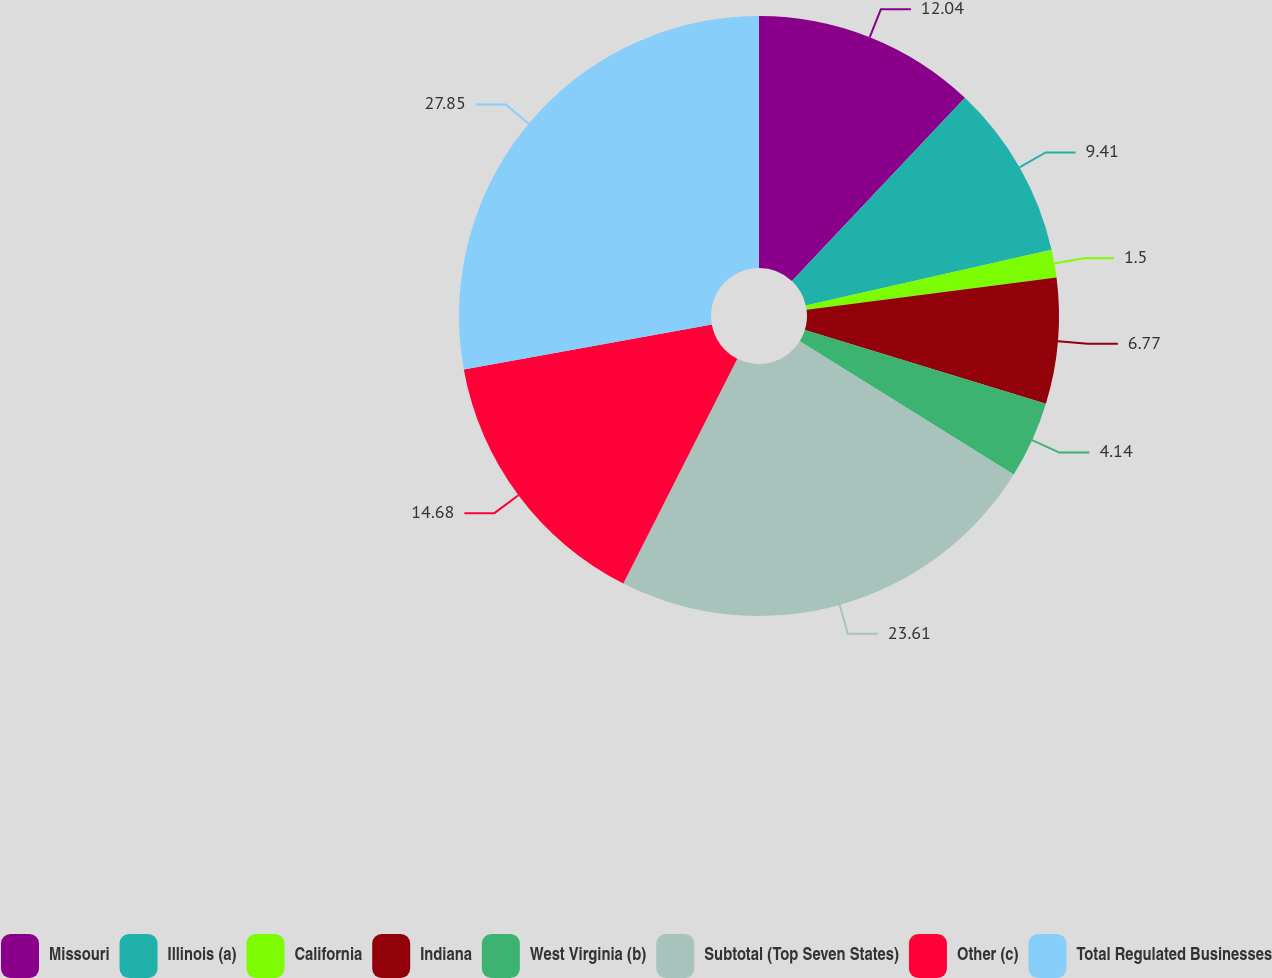Convert chart to OTSL. <chart><loc_0><loc_0><loc_500><loc_500><pie_chart><fcel>Missouri<fcel>Illinois (a)<fcel>California<fcel>Indiana<fcel>West Virginia (b)<fcel>Subtotal (Top Seven States)<fcel>Other (c)<fcel>Total Regulated Businesses<nl><fcel>12.04%<fcel>9.41%<fcel>1.5%<fcel>6.77%<fcel>4.14%<fcel>23.61%<fcel>14.68%<fcel>27.85%<nl></chart> 